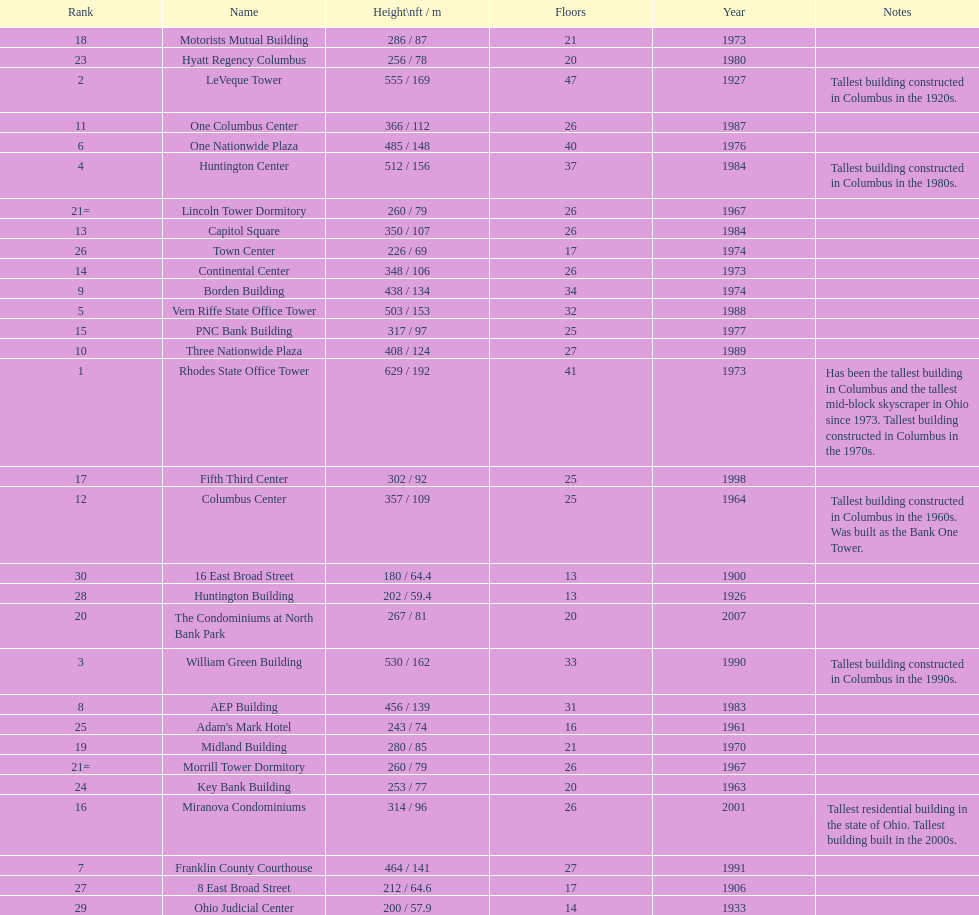Which is the tallest building? Rhodes State Office Tower. Write the full table. {'header': ['Rank', 'Name', 'Height\\nft / m', 'Floors', 'Year', 'Notes'], 'rows': [['18', 'Motorists Mutual Building', '286 / 87', '21', '1973', ''], ['23', 'Hyatt Regency Columbus', '256 / 78', '20', '1980', ''], ['2', 'LeVeque Tower', '555 / 169', '47', '1927', 'Tallest building constructed in Columbus in the 1920s.'], ['11', 'One Columbus Center', '366 / 112', '26', '1987', ''], ['6', 'One Nationwide Plaza', '485 / 148', '40', '1976', ''], ['4', 'Huntington Center', '512 / 156', '37', '1984', 'Tallest building constructed in Columbus in the 1980s.'], ['21=', 'Lincoln Tower Dormitory', '260 / 79', '26', '1967', ''], ['13', 'Capitol Square', '350 / 107', '26', '1984', ''], ['26', 'Town Center', '226 / 69', '17', '1974', ''], ['14', 'Continental Center', '348 / 106', '26', '1973', ''], ['9', 'Borden Building', '438 / 134', '34', '1974', ''], ['5', 'Vern Riffe State Office Tower', '503 / 153', '32', '1988', ''], ['15', 'PNC Bank Building', '317 / 97', '25', '1977', ''], ['10', 'Three Nationwide Plaza', '408 / 124', '27', '1989', ''], ['1', 'Rhodes State Office Tower', '629 / 192', '41', '1973', 'Has been the tallest building in Columbus and the tallest mid-block skyscraper in Ohio since 1973. Tallest building constructed in Columbus in the 1970s.'], ['17', 'Fifth Third Center', '302 / 92', '25', '1998', ''], ['12', 'Columbus Center', '357 / 109', '25', '1964', 'Tallest building constructed in Columbus in the 1960s. Was built as the Bank One Tower.'], ['30', '16 East Broad Street', '180 / 64.4', '13', '1900', ''], ['28', 'Huntington Building', '202 / 59.4', '13', '1926', ''], ['20', 'The Condominiums at North Bank Park', '267 / 81', '20', '2007', ''], ['3', 'William Green Building', '530 / 162', '33', '1990', 'Tallest building constructed in Columbus in the 1990s.'], ['8', 'AEP Building', '456 / 139', '31', '1983', ''], ['25', "Adam's Mark Hotel", '243 / 74', '16', '1961', ''], ['19', 'Midland Building', '280 / 85', '21', '1970', ''], ['21=', 'Morrill Tower Dormitory', '260 / 79', '26', '1967', ''], ['24', 'Key Bank Building', '253 / 77', '20', '1963', ''], ['16', 'Miranova Condominiums', '314 / 96', '26', '2001', 'Tallest residential building in the state of Ohio. Tallest building built in the 2000s.'], ['7', 'Franklin County Courthouse', '464 / 141', '27', '1991', ''], ['27', '8 East Broad Street', '212 / 64.6', '17', '1906', ''], ['29', 'Ohio Judicial Center', '200 / 57.9', '14', '1933', '']]} 